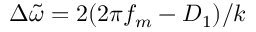<formula> <loc_0><loc_0><loc_500><loc_500>\Delta \widetilde { \omega } = 2 ( 2 \pi f _ { m } - D _ { 1 } ) / k</formula> 